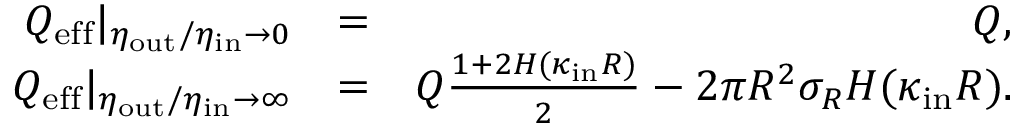Convert formula to latex. <formula><loc_0><loc_0><loc_500><loc_500>\begin{array} { r l r } { Q _ { e f f } | _ { \eta _ { o u t } / \eta _ { i n } \to 0 } } & { = } & { Q , } \\ { Q _ { e f f } | _ { \eta _ { o u t } / \eta _ { i n } \to \infty } } & { = } & { Q \frac { 1 + 2 H ( \kappa _ { i n } R ) } { 2 } - 2 \pi R ^ { 2 } \sigma _ { R } H ( \kappa _ { i n } R ) . } \end{array}</formula> 